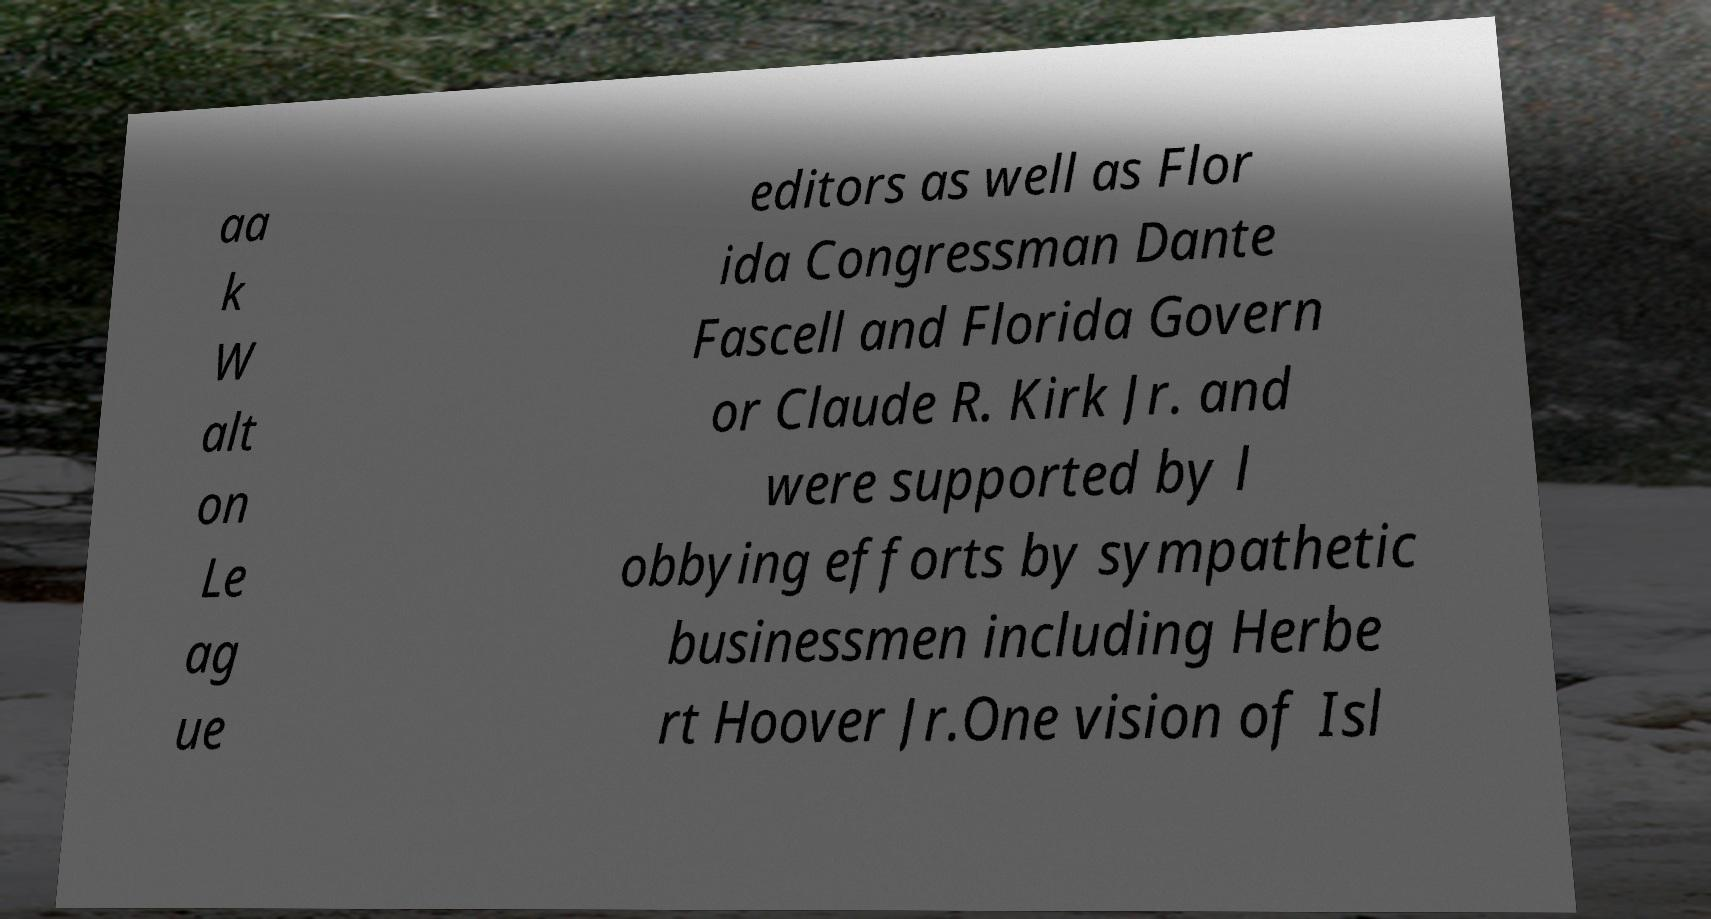I need the written content from this picture converted into text. Can you do that? aa k W alt on Le ag ue editors as well as Flor ida Congressman Dante Fascell and Florida Govern or Claude R. Kirk Jr. and were supported by l obbying efforts by sympathetic businessmen including Herbe rt Hoover Jr.One vision of Isl 